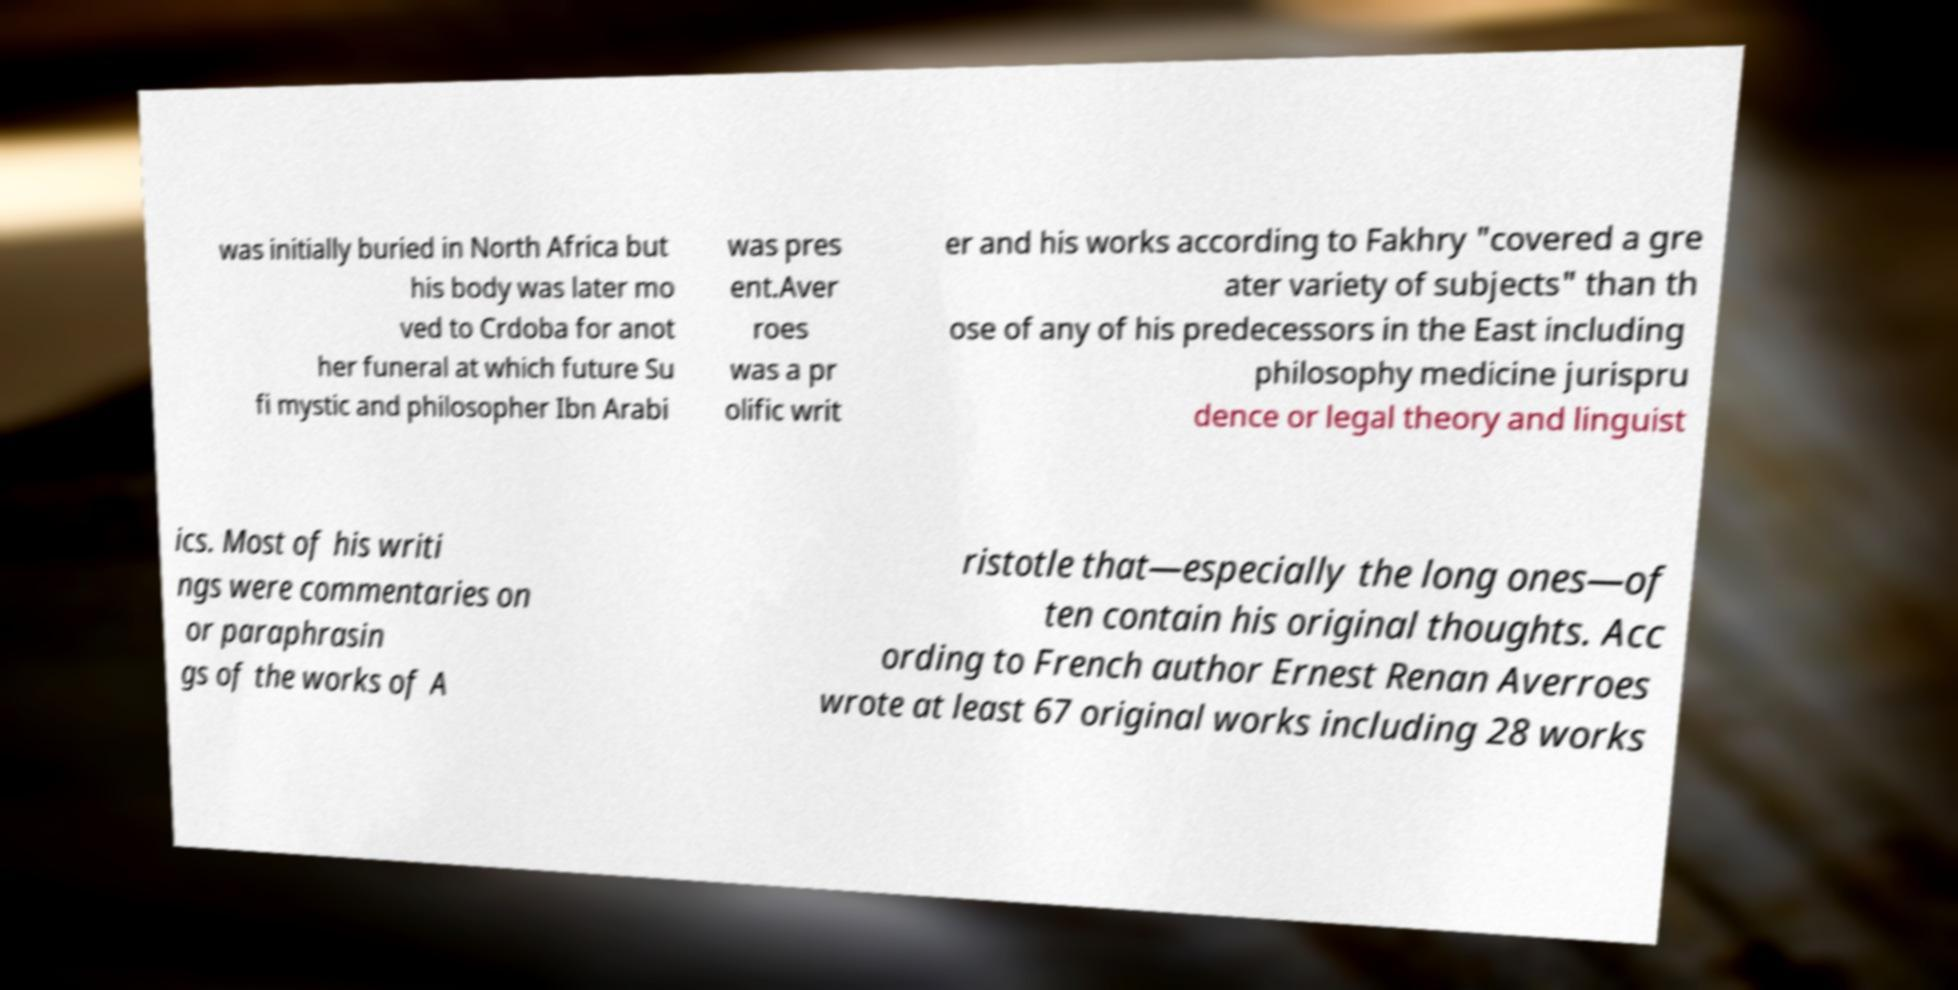Can you read and provide the text displayed in the image?This photo seems to have some interesting text. Can you extract and type it out for me? was initially buried in North Africa but his body was later mo ved to Crdoba for anot her funeral at which future Su fi mystic and philosopher Ibn Arabi was pres ent.Aver roes was a pr olific writ er and his works according to Fakhry "covered a gre ater variety of subjects" than th ose of any of his predecessors in the East including philosophy medicine jurispru dence or legal theory and linguist ics. Most of his writi ngs were commentaries on or paraphrasin gs of the works of A ristotle that—especially the long ones—of ten contain his original thoughts. Acc ording to French author Ernest Renan Averroes wrote at least 67 original works including 28 works 